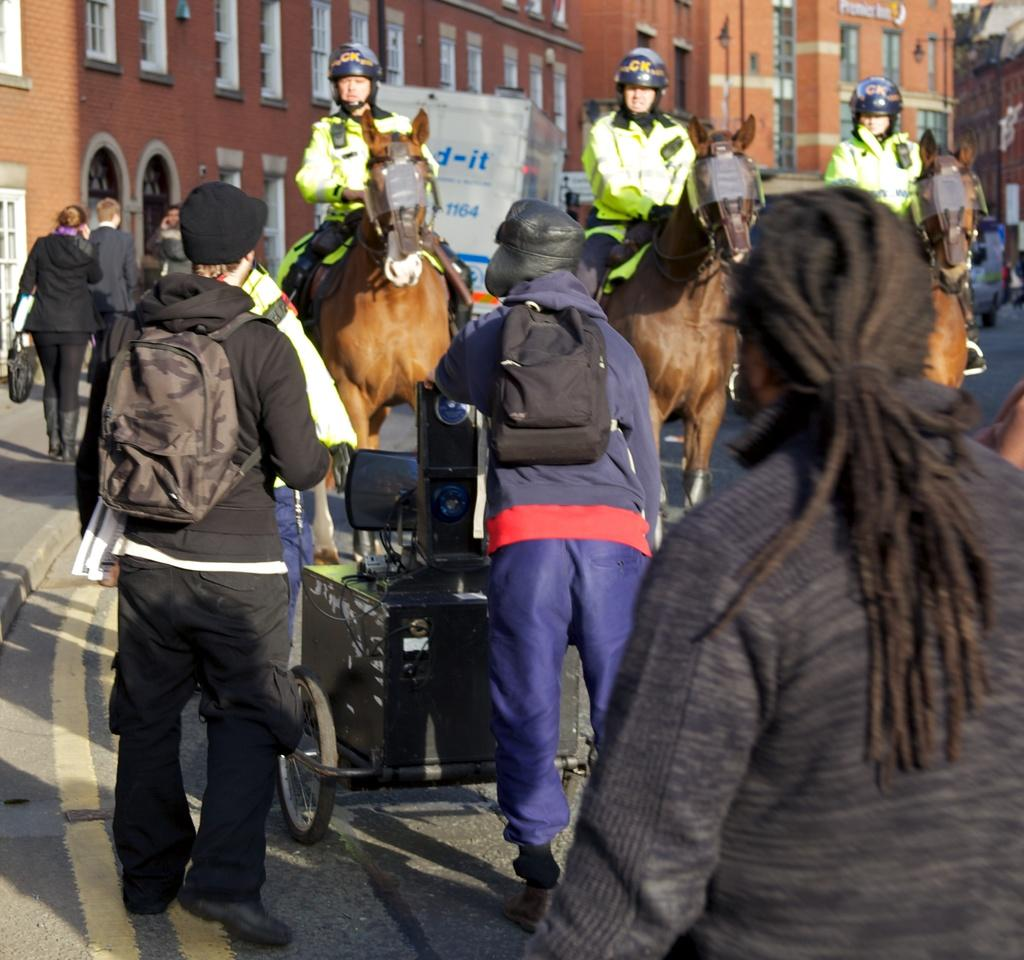What can be seen in the background of the image? There are buildings in the background of the image. What activity is taking place on the road? There are persons riding horses on the road. What are some of the persons carrying while walking? There are persons wearing backpacks and walking. What is another activity taking place on the road? There are persons walking on the road. Can you see any bears walking alongside the persons on the road? No, there are no bears present in the image. What type of fowl can be seen flying over the persons riding horses? There are no fowl visible in the image; it only shows persons riding horses and walking on the road. 